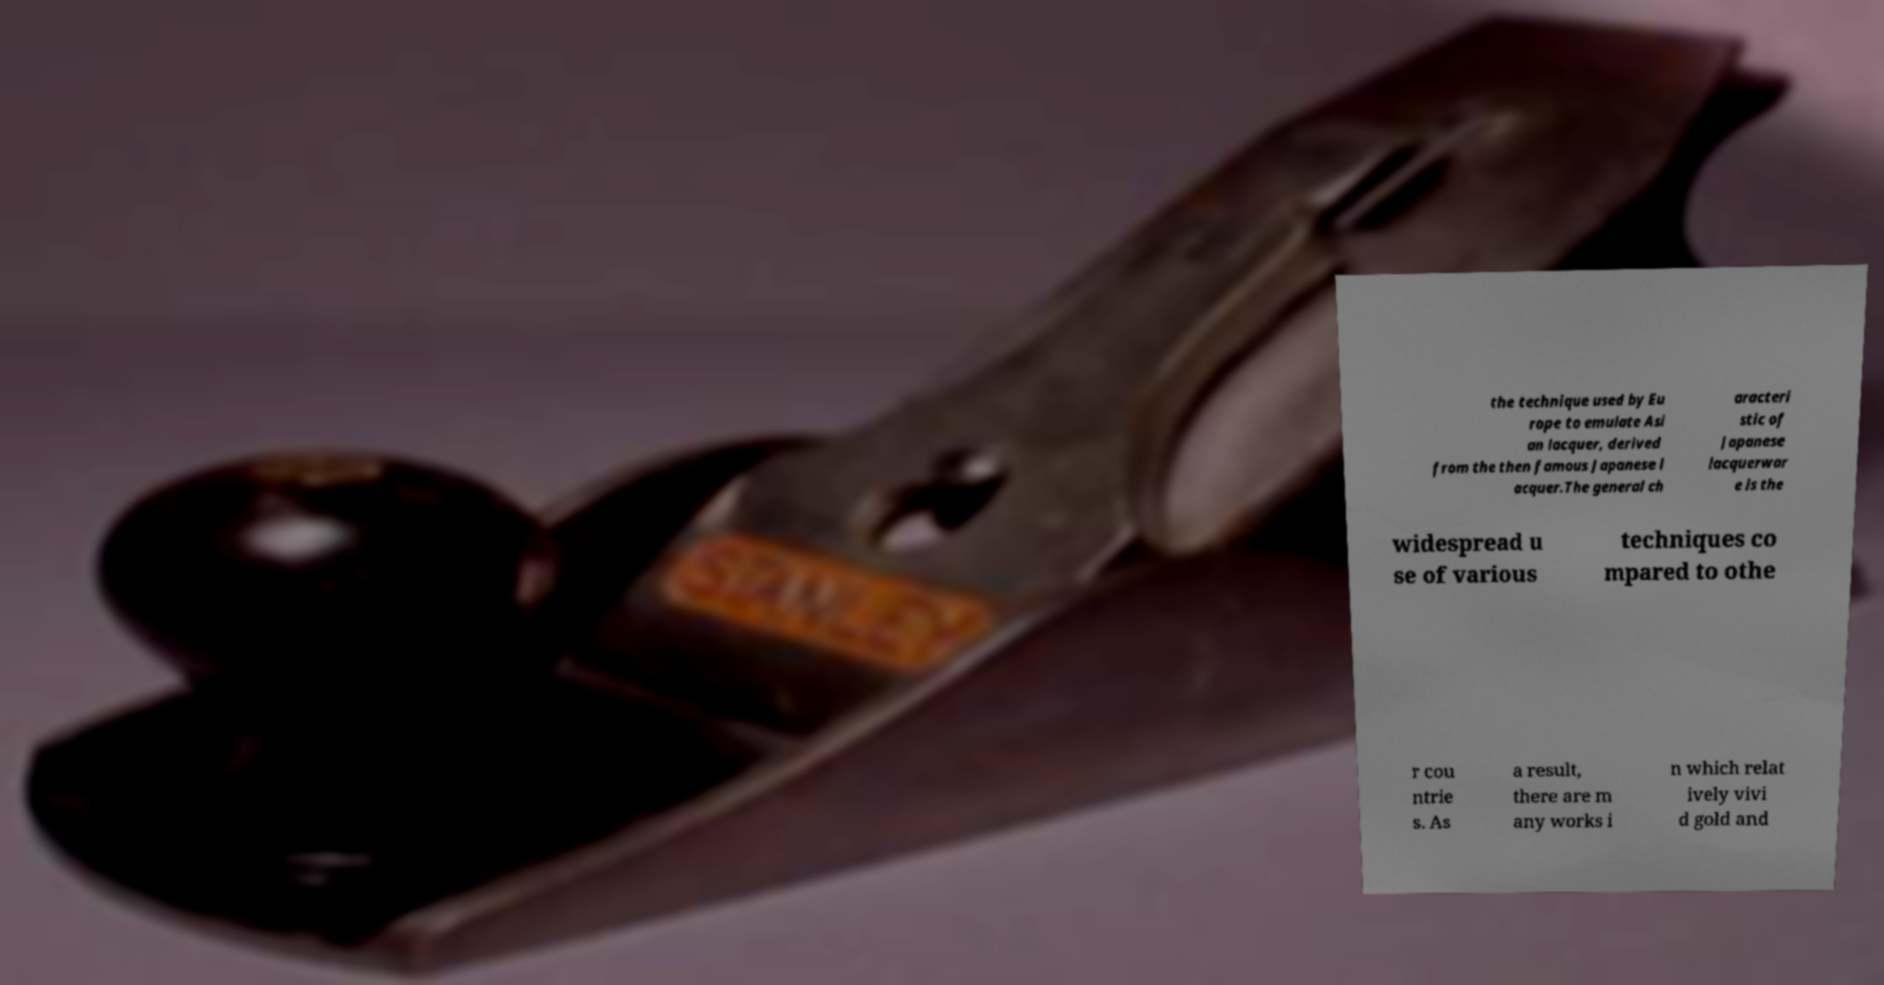What messages or text are displayed in this image? I need them in a readable, typed format. the technique used by Eu rope to emulate Asi an lacquer, derived from the then famous Japanese l acquer.The general ch aracteri stic of Japanese lacquerwar e is the widespread u se of various techniques co mpared to othe r cou ntrie s. As a result, there are m any works i n which relat ively vivi d gold and 